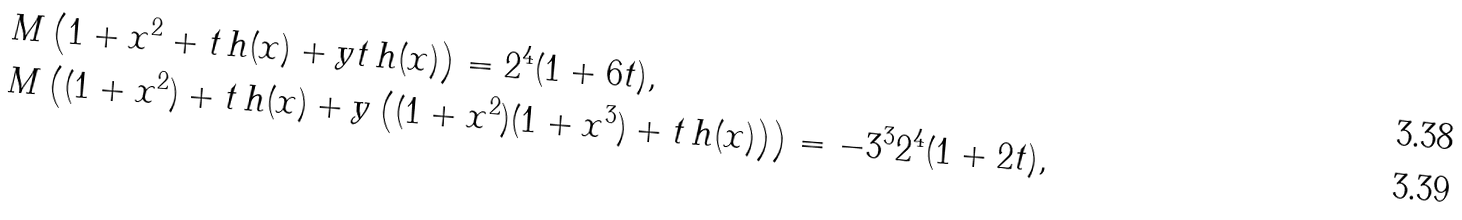<formula> <loc_0><loc_0><loc_500><loc_500>& M \left ( 1 + x ^ { 2 } + t \, h ( x ) + y t \, h ( x ) \right ) = 2 ^ { 4 } ( 1 + 6 t ) , \\ & M \left ( ( 1 + x ^ { 2 } ) + t \, h ( x ) + y \left ( ( 1 + x ^ { 2 } ) ( 1 + x ^ { 3 } ) + t \, h ( x ) \right ) \right ) = - 3 ^ { 3 } 2 ^ { 4 } ( 1 + 2 t ) ,</formula> 